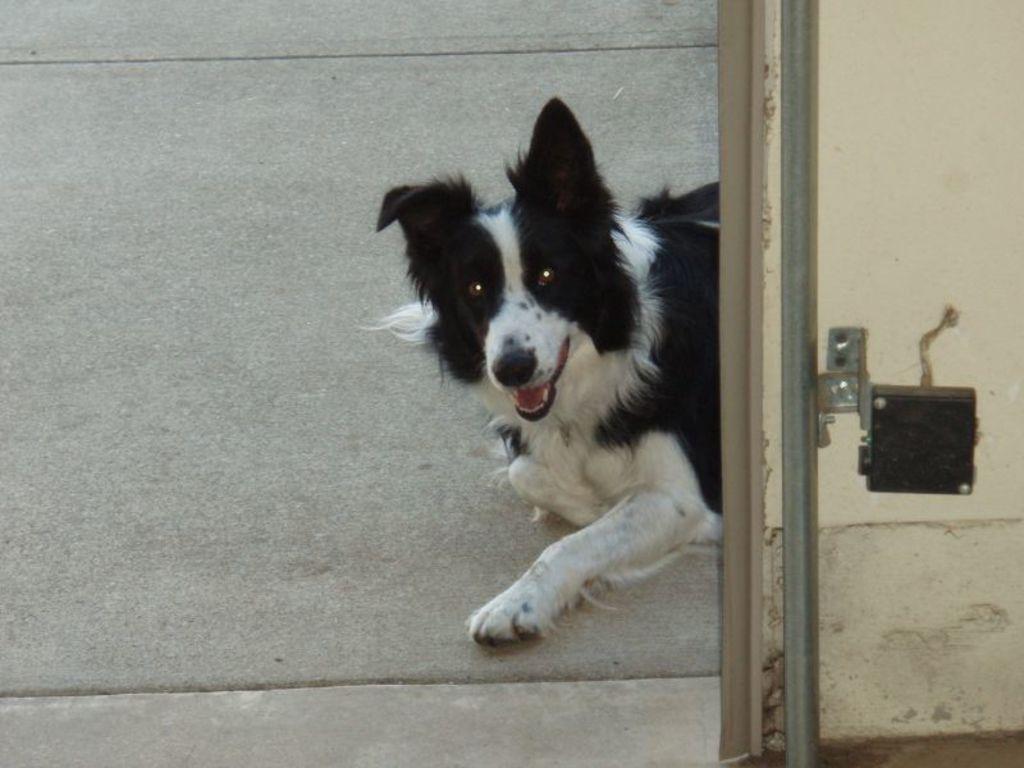How would you summarize this image in a sentence or two? We can see dog on the surface. We can see rod and device on a wall. 